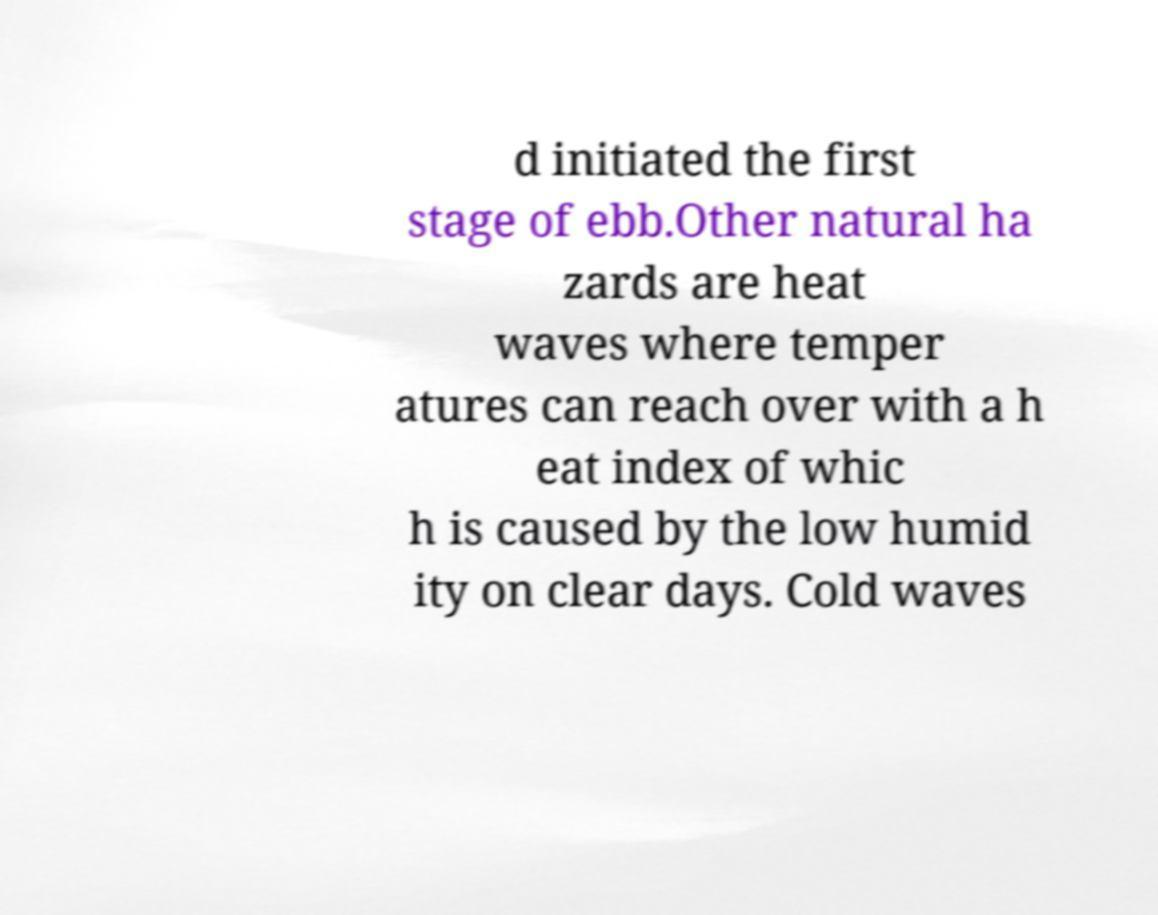I need the written content from this picture converted into text. Can you do that? d initiated the first stage of ebb.Other natural ha zards are heat waves where temper atures can reach over with a h eat index of whic h is caused by the low humid ity on clear days. Cold waves 